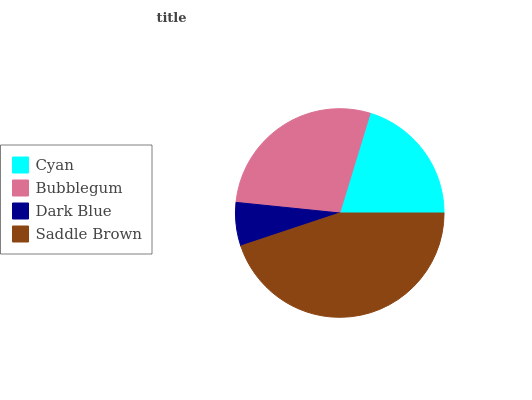Is Dark Blue the minimum?
Answer yes or no. Yes. Is Saddle Brown the maximum?
Answer yes or no. Yes. Is Bubblegum the minimum?
Answer yes or no. No. Is Bubblegum the maximum?
Answer yes or no. No. Is Bubblegum greater than Cyan?
Answer yes or no. Yes. Is Cyan less than Bubblegum?
Answer yes or no. Yes. Is Cyan greater than Bubblegum?
Answer yes or no. No. Is Bubblegum less than Cyan?
Answer yes or no. No. Is Bubblegum the high median?
Answer yes or no. Yes. Is Cyan the low median?
Answer yes or no. Yes. Is Saddle Brown the high median?
Answer yes or no. No. Is Dark Blue the low median?
Answer yes or no. No. 